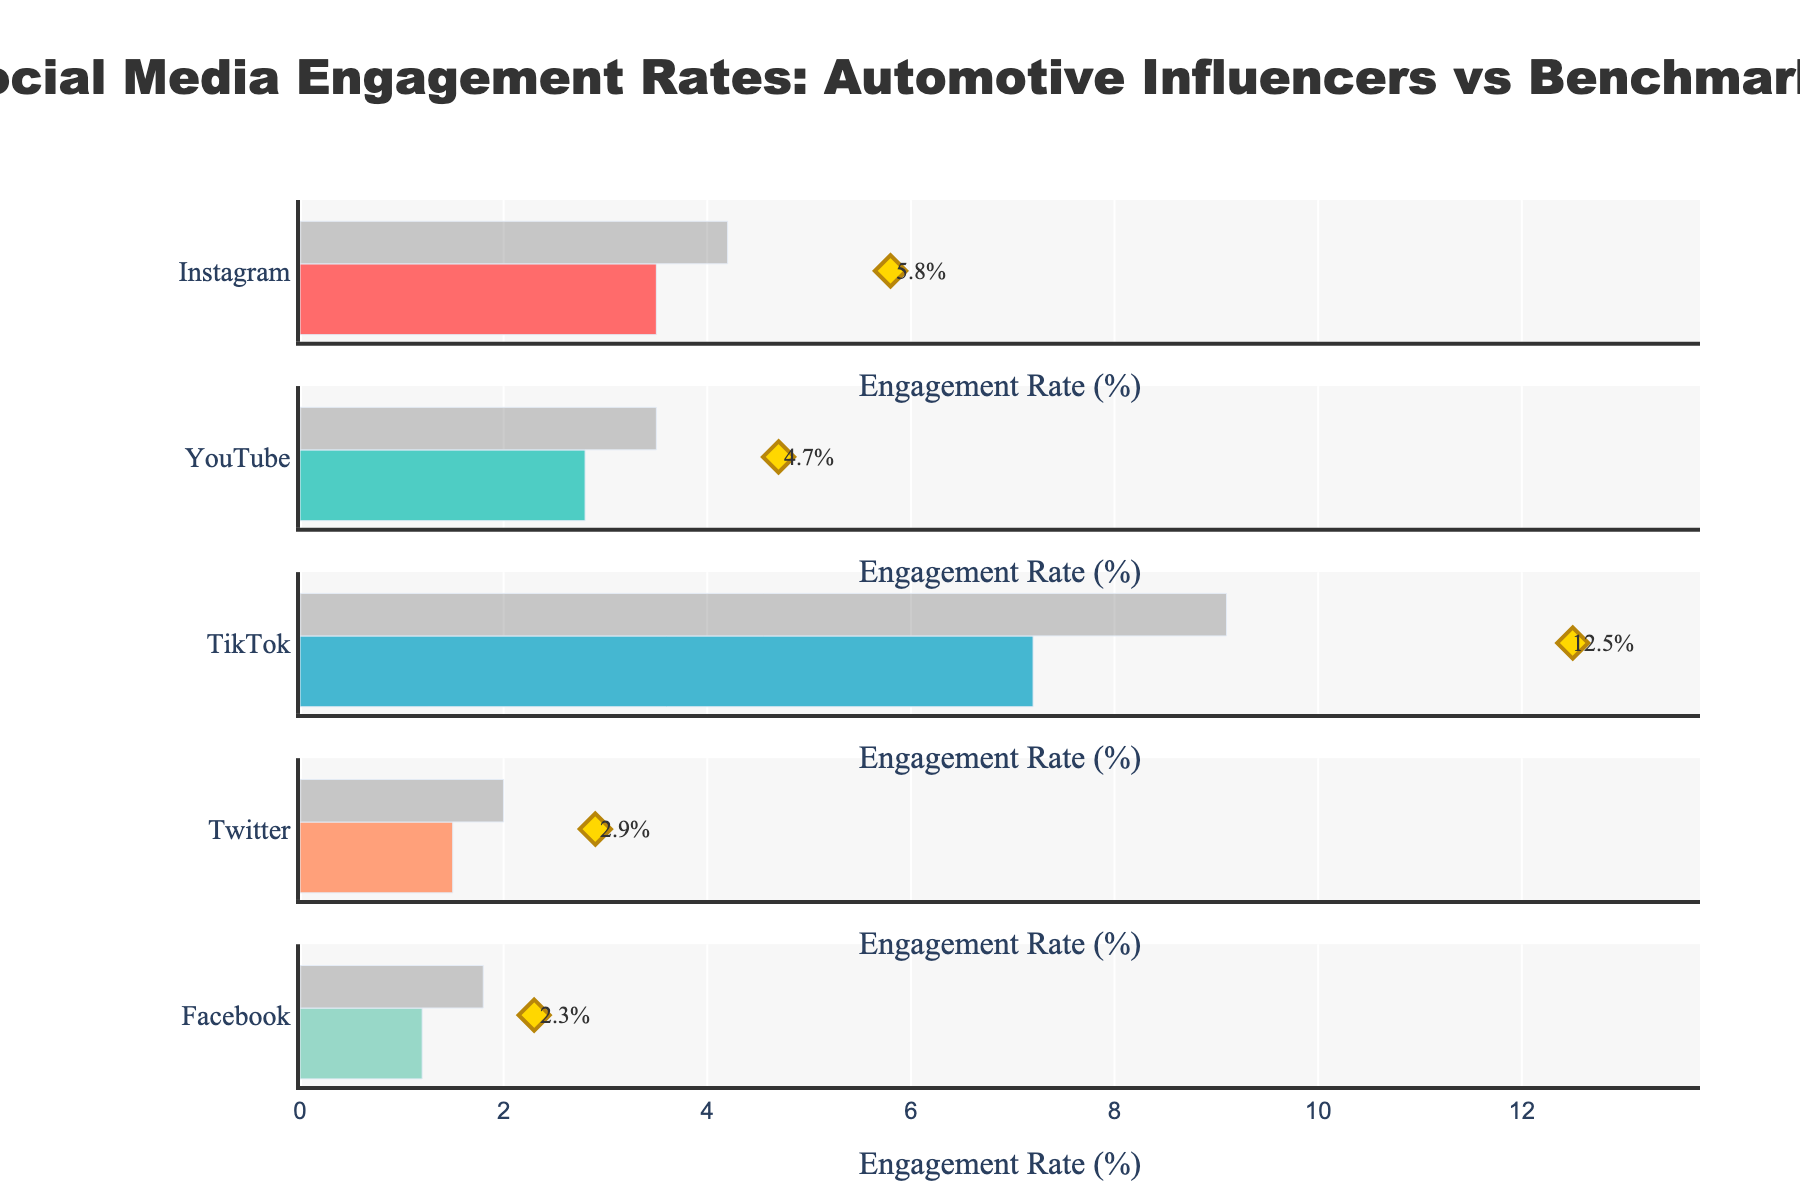What's the highest engagement rate for automotive influencers on any platform? In the plot, TikTok shows the highest influencer engagement rate, represented by a yellow diamond at 12.5%.
Answer: 12.5% On which platform do automotive influencers outperform the benchmark by the greatest margin? Comparing influencer rates to benchmark rates across all platforms, TikTok has the largest difference, where influencers have a 12.5% engagement rate compared to the benchmark of 9.1%.
Answer: TikTok Which platform has the closest influencer engagement rate to its benchmark? By comparing the influencer rates and benchmarks, Facebook’s influencer rate of 2.3% and benchmark of 1.8% have the smallest difference of 0.5%.
Answer: Facebook How much greater is the engagement rate of automotive influencers on Instagram compared to the average on Instagram? The Instagram influencer rate is 5.8% and the average is 3.5%. The difference is 5.8% - 3.5% = 2.3%.
Answer: 2.3% Which platform has the lowest average engagement rate? The lowest average engagement rate is on Facebook, which shows a bar extending to 1.2% on the x-axis.
Answer: Facebook On which platform is the influencer rate more than double the average engagement rate? TikTok’s influencer rate is 12.5% compared to an average of 7.2%, and 12.5% is more than double 7.2%.
Answer: TikTok How does the Instagram benchmark compare to the influencer rate on Twitter? The Instagram benchmark is 4.2% and the Twitter influencer rate is 2.9%. The Instagram benchmark is higher.
Answer: Instagram benchmark is higher By how much do automotive influencers on YouTube exceed their platform's average engagement rate? The YouTube influencer rate is 4.7% and the average rate is 2.8%. The difference is 4.7% - 2.8% = 1.9%.
Answer: 1.9% Is the influencer engagement rate on Facebook higher than the benchmark on Twitter? The influencer engagement rate on Facebook is 2.3%, and the Twitter benchmark is 2.0%. Since 2.3% > 2.0%, Facebook influencers have a higher rate.
Answer: Yes 